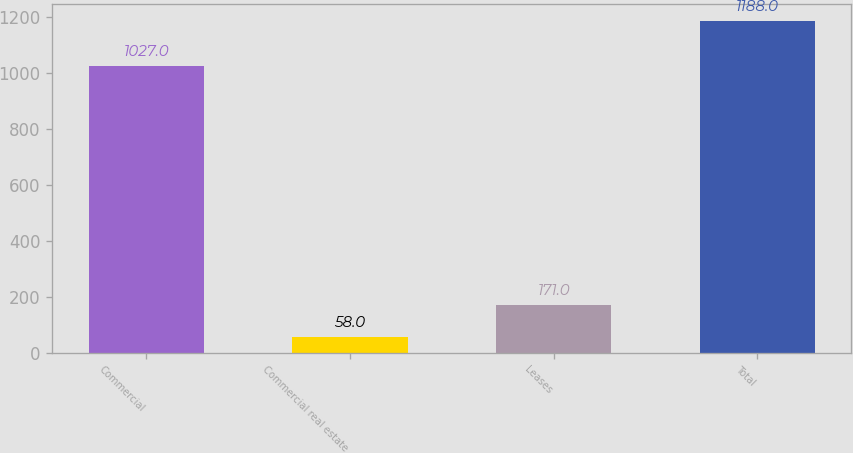Convert chart. <chart><loc_0><loc_0><loc_500><loc_500><bar_chart><fcel>Commercial<fcel>Commercial real estate<fcel>Leases<fcel>Total<nl><fcel>1027<fcel>58<fcel>171<fcel>1188<nl></chart> 